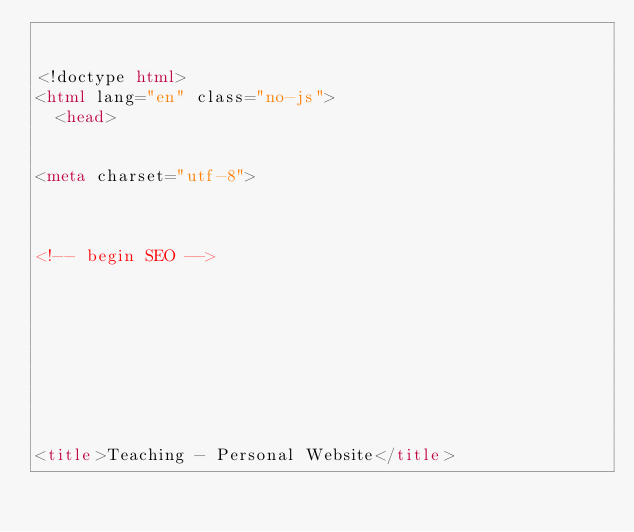Convert code to text. <code><loc_0><loc_0><loc_500><loc_500><_HTML_>

<!doctype html>
<html lang="en" class="no-js">
  <head>
    

<meta charset="utf-8">



<!-- begin SEO -->









<title>Teaching - Personal Website</title>






</code> 